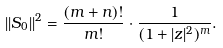Convert formula to latex. <formula><loc_0><loc_0><loc_500><loc_500>| | S _ { 0 } | | ^ { 2 } = { \frac { ( m + n ) ! } { m ! } } \cdot \frac { 1 } { ( 1 + | z | ^ { 2 } ) ^ { m } } .</formula> 